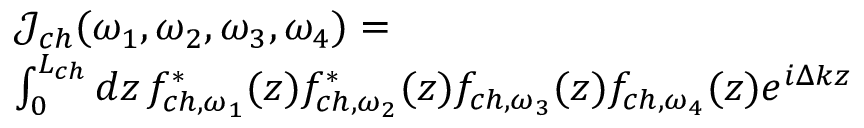<formula> <loc_0><loc_0><loc_500><loc_500>\begin{array} { r l } & { \mathcal { J } _ { c h } ( \omega _ { 1 } , \omega _ { 2 } , \omega _ { 3 } , \omega _ { 4 } ) = } \\ & { \int _ { 0 } ^ { L _ { c h } } d z \, { f } _ { c h , \omega _ { 1 } } ^ { * } ( z ) { f } _ { c h , \omega _ { 2 } } ^ { * } ( z ) { f } _ { c h , \omega _ { 3 } } ( z ) { f } _ { c h , \omega _ { 4 } } ( z ) e ^ { i \Delta k z } } \end{array}</formula> 